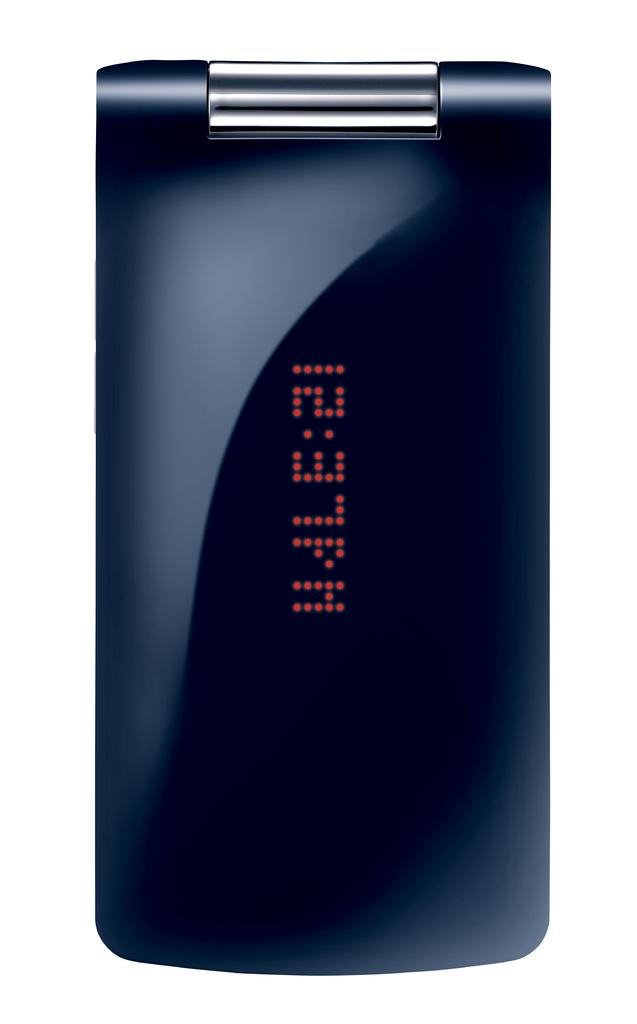Provide a one-sentence caption for the provided image. A closed electronic device has a time display on the cover. 